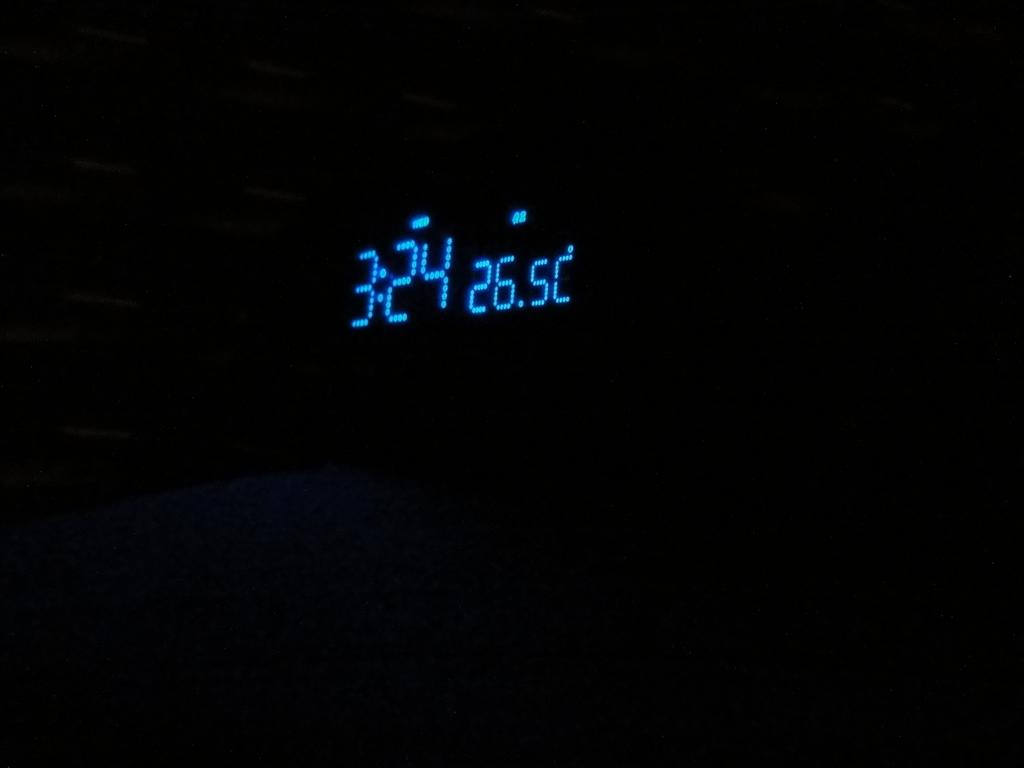<image>
Create a compact narrative representing the image presented. a digital clock in the dark that reads '3:24' on it 